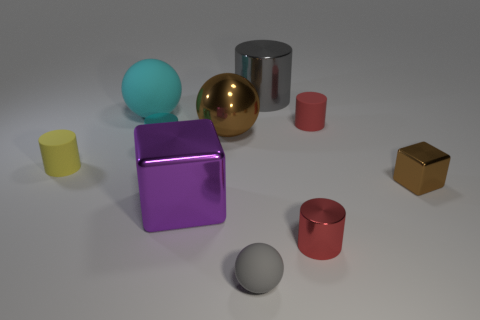Subtract all red cylinders. How many were subtracted if there are1red cylinders left? 1 Subtract all big brown spheres. How many spheres are left? 2 Subtract all gray balls. How many balls are left? 2 Subtract 2 blocks. How many blocks are left? 0 Subtract all balls. How many objects are left? 7 Subtract all green cylinders. How many cyan balls are left? 1 Add 5 metallic spheres. How many metallic spheres are left? 6 Add 1 large purple metallic blocks. How many large purple metallic blocks exist? 2 Subtract 2 red cylinders. How many objects are left? 8 Subtract all blue cylinders. Subtract all red spheres. How many cylinders are left? 5 